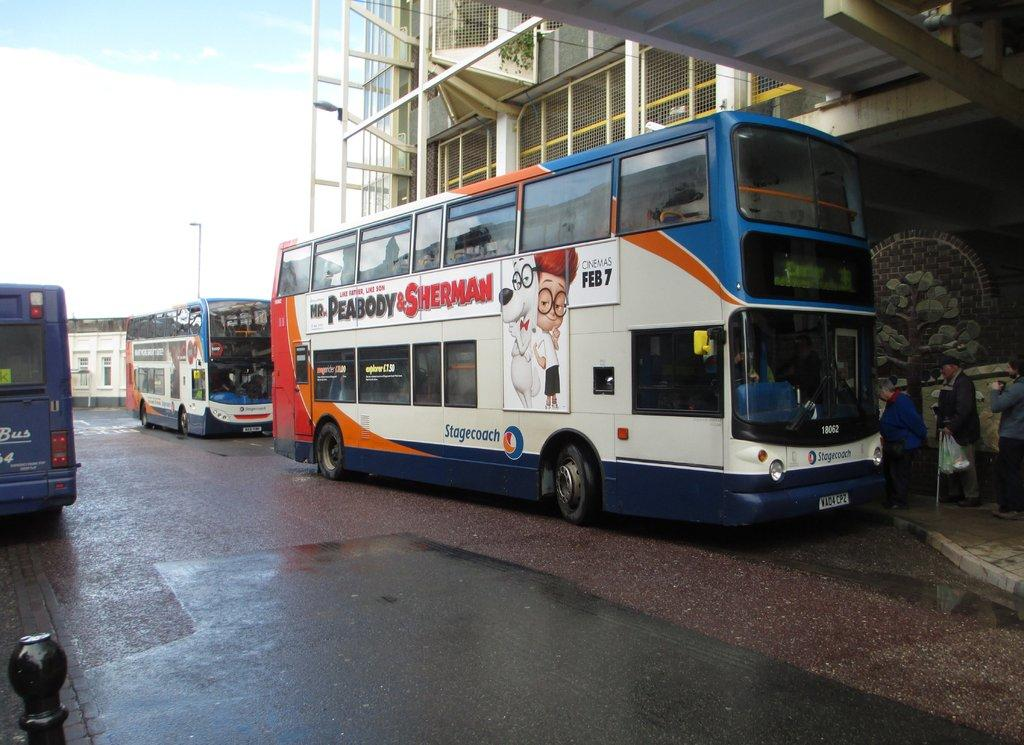What can be seen in the image? There are vehicles in the image. Can you describe the people on the right side of the image? There are three people with different color dresses on the right side of the image. What is visible in the background of the image? There are buildings, a pole, clouds, and the sky visible in the background of the image. What type of corn is being weighed on a scale in the image? There is no corn or scale present in the image. 